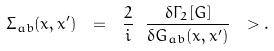Convert formula to latex. <formula><loc_0><loc_0><loc_500><loc_500>\Sigma _ { a b } ( x , x ^ { \prime } ) \ = \ \frac { 2 } { i } \ \frac { \delta \Gamma _ { 2 } [ G ] } { \delta G _ { a b } ( x , x ^ { \prime } ) } \ > .</formula> 